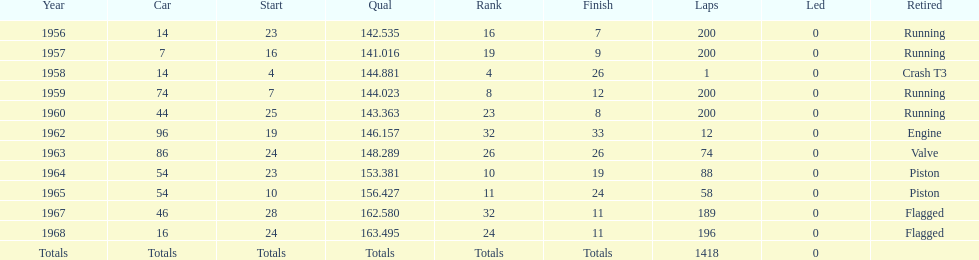In what year was his car's number the same as it was in 1964? 1965. 